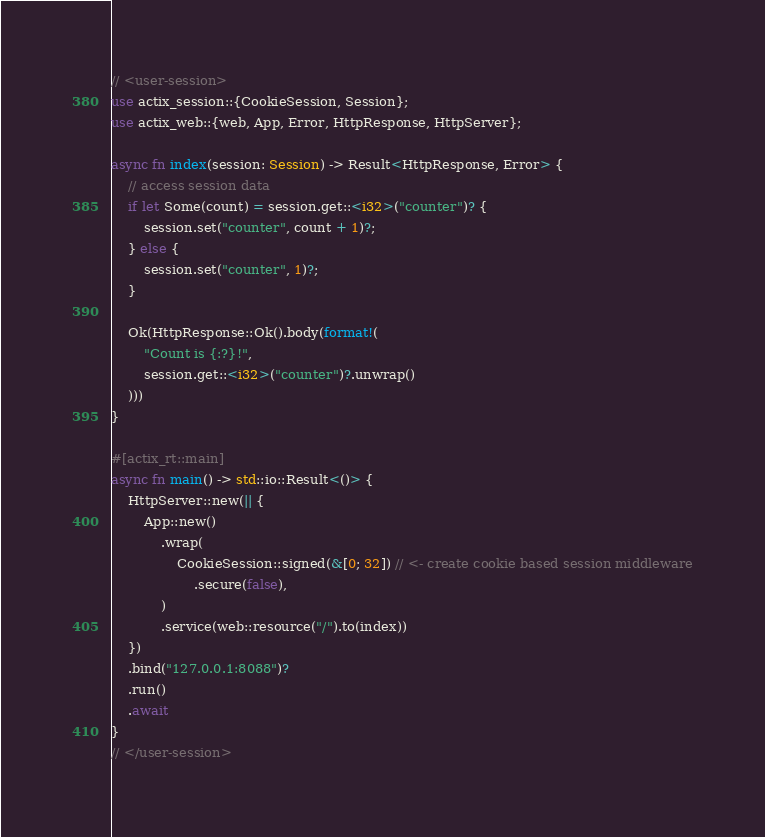Convert code to text. <code><loc_0><loc_0><loc_500><loc_500><_Rust_>// <user-session>
use actix_session::{CookieSession, Session};
use actix_web::{web, App, Error, HttpResponse, HttpServer};

async fn index(session: Session) -> Result<HttpResponse, Error> {
    // access session data
    if let Some(count) = session.get::<i32>("counter")? {
        session.set("counter", count + 1)?;
    } else {
        session.set("counter", 1)?;
    }

    Ok(HttpResponse::Ok().body(format!(
        "Count is {:?}!",
        session.get::<i32>("counter")?.unwrap()
    )))
}

#[actix_rt::main]
async fn main() -> std::io::Result<()> {
    HttpServer::new(|| {
        App::new()
            .wrap(
                CookieSession::signed(&[0; 32]) // <- create cookie based session middleware
                    .secure(false),
            )
            .service(web::resource("/").to(index))
    })
    .bind("127.0.0.1:8088")?
    .run()
    .await
}
// </user-session>
</code> 